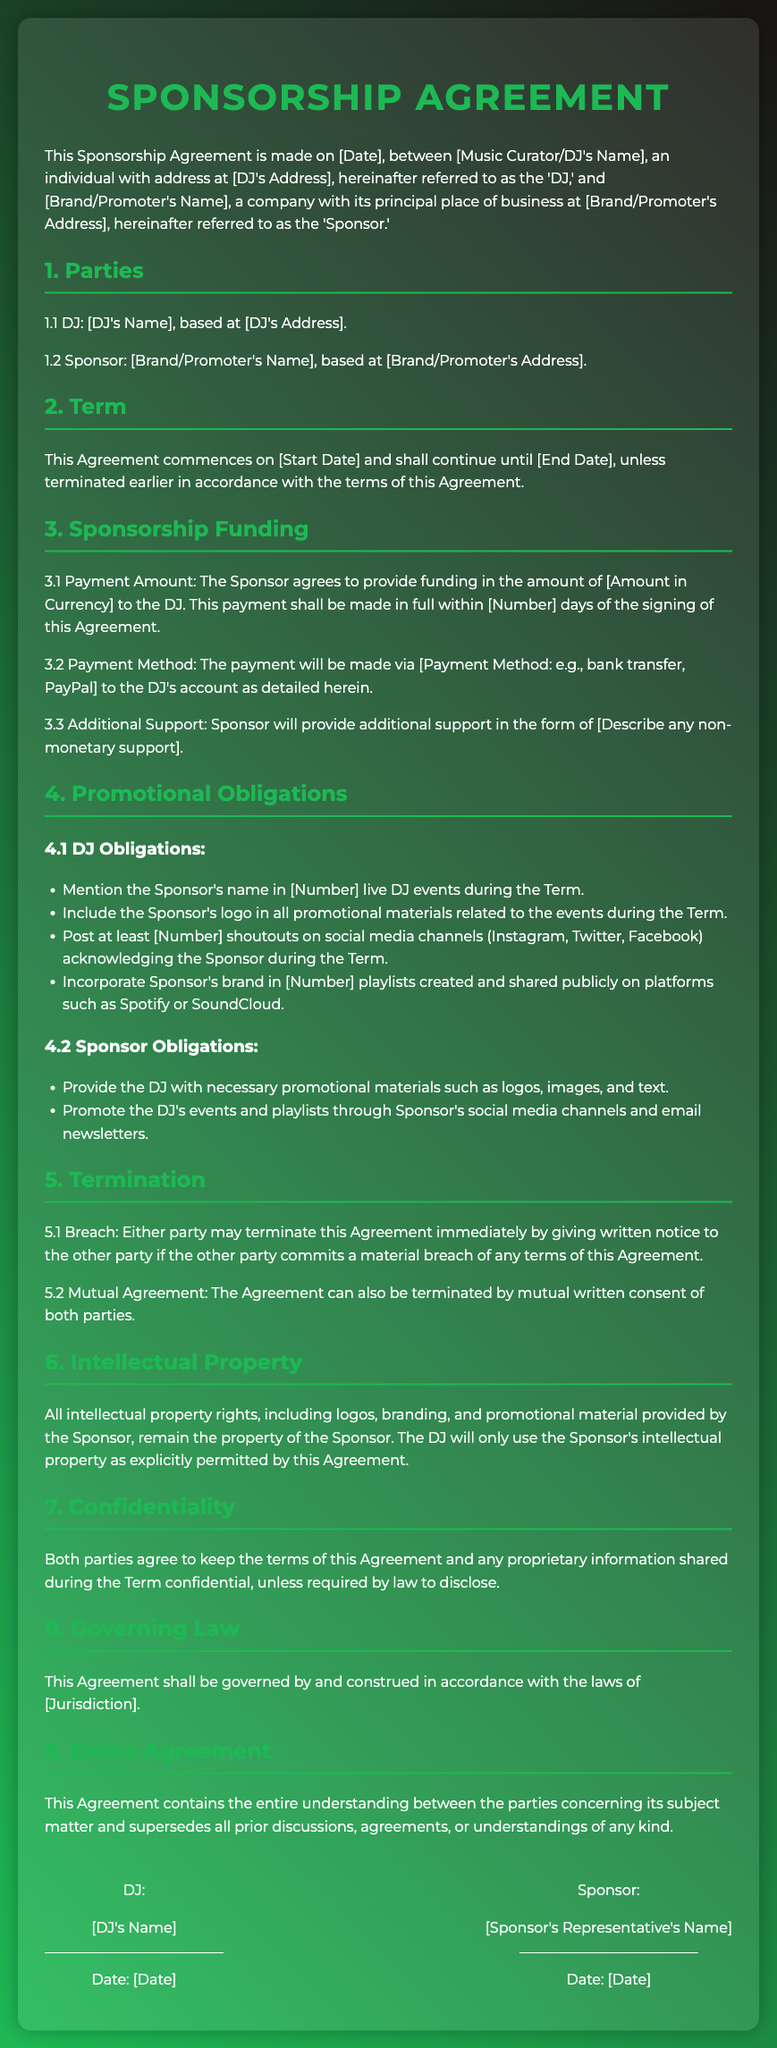What is the date the Agreement is made? The date is specified as [Date], which should be filled out in the document.
Answer: [Date] Who is the DJ in the Agreement? The DJ's name is given as [DJ's Name], indicated in the parties section of the document.
Answer: [DJ's Name] What is the funding amount agreed upon? The funding amount is stated as [Amount in Currency], which is part of the sponsorship funding section.
Answer: [Amount in Currency] How many live DJ events must the DJ mention the Sponsor's name? The document specifies the number of events as [Number], found in the DJ obligations section.
Answer: [Number] What does the Sponsor provide in terms of promotional materials? The Sponsor is required to provide promotional materials such as logos, images, and text.
Answer: Logos, images, and text What happens if either party breaches the Agreement? The document states that either party may terminate this Agreement immediately upon giving written notice of a material breach.
Answer: Termination Can the Agreement be terminated by mutual consent? Yes, the Agreement can be terminated by mutual written consent of both parties, which is explained in the termination section.
Answer: Yes Where will the Agreement be governed? The governing law of the Agreement is outlined to be [Jurisdiction], found in the governing law section.
Answer: [Jurisdiction] What is the totality of the Agreement referred to in the document? It is referred to as the entire understanding between the parties concerning its subject matter.
Answer: Entire Agreement 